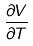Convert formula to latex. <formula><loc_0><loc_0><loc_500><loc_500>\frac { \partial V } { \partial T }</formula> 